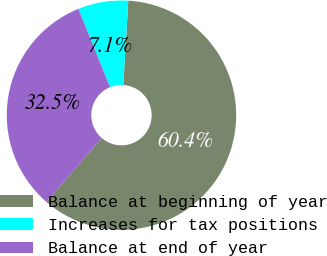<chart> <loc_0><loc_0><loc_500><loc_500><pie_chart><fcel>Balance at beginning of year<fcel>Increases for tax positions<fcel>Balance at end of year<nl><fcel>60.39%<fcel>7.08%<fcel>32.52%<nl></chart> 